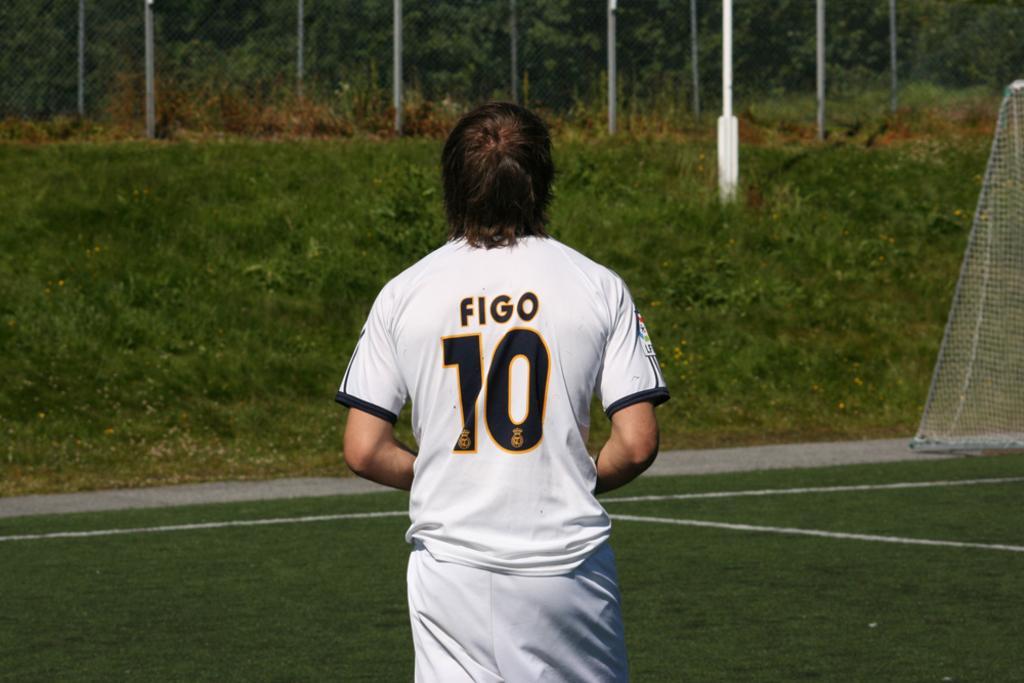Please provide a concise description of this image. In this image, at the middle there is a person standing, he is wearing a white color t-shirt, on that t-shirt there is FIGO 10 written, at the background there are some green color plants and there are some poles, at the right side there are some poles. 